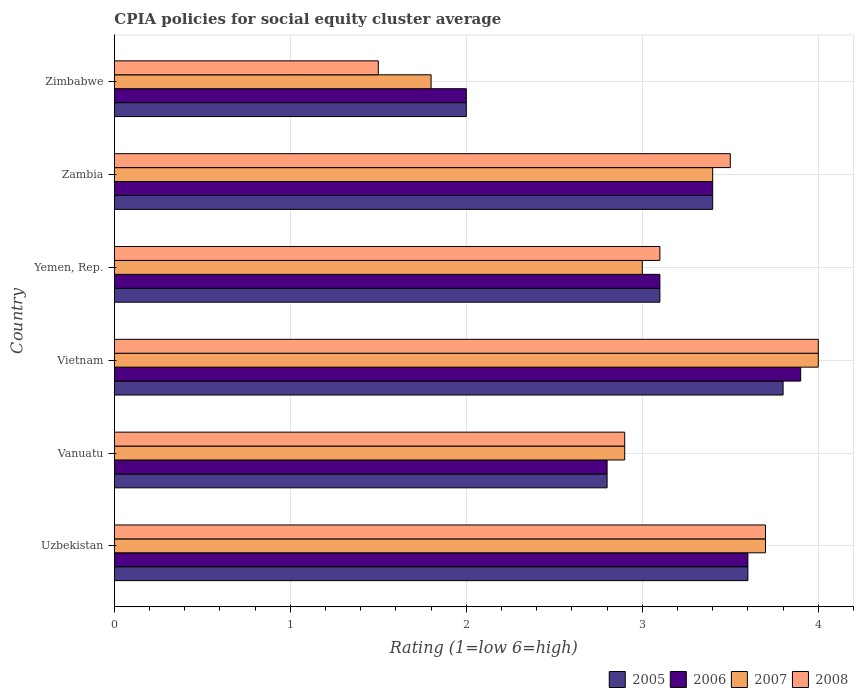Are the number of bars per tick equal to the number of legend labels?
Provide a succinct answer. Yes. How many bars are there on the 4th tick from the bottom?
Make the answer very short. 4. What is the label of the 3rd group of bars from the top?
Your response must be concise. Yemen, Rep. In how many cases, is the number of bars for a given country not equal to the number of legend labels?
Offer a terse response. 0. What is the CPIA rating in 2008 in Yemen, Rep.?
Your answer should be compact. 3.1. Across all countries, what is the maximum CPIA rating in 2006?
Offer a very short reply. 3.9. Across all countries, what is the minimum CPIA rating in 2005?
Offer a terse response. 2. In which country was the CPIA rating in 2006 maximum?
Provide a succinct answer. Vietnam. In which country was the CPIA rating in 2008 minimum?
Keep it short and to the point. Zimbabwe. What is the difference between the CPIA rating in 2006 in Yemen, Rep. and that in Zimbabwe?
Ensure brevity in your answer.  1.1. What is the difference between the CPIA rating in 2008 in Vietnam and the CPIA rating in 2005 in Vanuatu?
Offer a very short reply. 1.2. What is the average CPIA rating in 2007 per country?
Provide a short and direct response. 3.13. What is the difference between the CPIA rating in 2006 and CPIA rating in 2007 in Zimbabwe?
Your answer should be compact. 0.2. What is the ratio of the CPIA rating in 2005 in Uzbekistan to that in Vanuatu?
Offer a terse response. 1.29. Is the difference between the CPIA rating in 2006 in Vietnam and Zimbabwe greater than the difference between the CPIA rating in 2007 in Vietnam and Zimbabwe?
Offer a very short reply. No. What is the difference between the highest and the second highest CPIA rating in 2008?
Your response must be concise. 0.3. What is the difference between the highest and the lowest CPIA rating in 2005?
Keep it short and to the point. 1.8. In how many countries, is the CPIA rating in 2007 greater than the average CPIA rating in 2007 taken over all countries?
Offer a very short reply. 3. Is it the case that in every country, the sum of the CPIA rating in 2007 and CPIA rating in 2008 is greater than the sum of CPIA rating in 2006 and CPIA rating in 2005?
Your response must be concise. No. How many bars are there?
Ensure brevity in your answer.  24. Are all the bars in the graph horizontal?
Your answer should be very brief. Yes. What is the difference between two consecutive major ticks on the X-axis?
Offer a very short reply. 1. Are the values on the major ticks of X-axis written in scientific E-notation?
Ensure brevity in your answer.  No. Does the graph contain grids?
Provide a short and direct response. Yes. Where does the legend appear in the graph?
Provide a short and direct response. Bottom right. How many legend labels are there?
Your response must be concise. 4. What is the title of the graph?
Provide a succinct answer. CPIA policies for social equity cluster average. Does "1988" appear as one of the legend labels in the graph?
Provide a short and direct response. No. What is the label or title of the X-axis?
Your answer should be compact. Rating (1=low 6=high). What is the label or title of the Y-axis?
Offer a very short reply. Country. What is the Rating (1=low 6=high) in 2005 in Uzbekistan?
Your answer should be compact. 3.6. What is the Rating (1=low 6=high) in 2006 in Uzbekistan?
Provide a succinct answer. 3.6. What is the Rating (1=low 6=high) in 2007 in Uzbekistan?
Provide a succinct answer. 3.7. What is the Rating (1=low 6=high) in 2008 in Uzbekistan?
Your response must be concise. 3.7. What is the Rating (1=low 6=high) in 2007 in Vanuatu?
Give a very brief answer. 2.9. What is the Rating (1=low 6=high) in 2005 in Vietnam?
Offer a terse response. 3.8. What is the Rating (1=low 6=high) of 2006 in Yemen, Rep.?
Provide a succinct answer. 3.1. What is the Rating (1=low 6=high) in 2007 in Yemen, Rep.?
Offer a terse response. 3. What is the Rating (1=low 6=high) in 2008 in Yemen, Rep.?
Offer a very short reply. 3.1. What is the Rating (1=low 6=high) of 2006 in Zambia?
Provide a succinct answer. 3.4. What is the Rating (1=low 6=high) of 2007 in Zambia?
Keep it short and to the point. 3.4. What is the Rating (1=low 6=high) of 2008 in Zambia?
Your response must be concise. 3.5. What is the Rating (1=low 6=high) in 2006 in Zimbabwe?
Offer a very short reply. 2. What is the Rating (1=low 6=high) in 2008 in Zimbabwe?
Offer a terse response. 1.5. Across all countries, what is the maximum Rating (1=low 6=high) of 2006?
Your answer should be compact. 3.9. Across all countries, what is the maximum Rating (1=low 6=high) of 2007?
Keep it short and to the point. 4. Across all countries, what is the minimum Rating (1=low 6=high) of 2007?
Provide a short and direct response. 1.8. Across all countries, what is the minimum Rating (1=low 6=high) in 2008?
Your response must be concise. 1.5. What is the total Rating (1=low 6=high) in 2008 in the graph?
Your answer should be very brief. 18.7. What is the difference between the Rating (1=low 6=high) in 2007 in Uzbekistan and that in Vanuatu?
Your response must be concise. 0.8. What is the difference between the Rating (1=low 6=high) of 2005 in Uzbekistan and that in Vietnam?
Provide a succinct answer. -0.2. What is the difference between the Rating (1=low 6=high) in 2006 in Uzbekistan and that in Yemen, Rep.?
Your response must be concise. 0.5. What is the difference between the Rating (1=low 6=high) of 2006 in Uzbekistan and that in Zambia?
Make the answer very short. 0.2. What is the difference between the Rating (1=low 6=high) in 2008 in Uzbekistan and that in Zambia?
Offer a terse response. 0.2. What is the difference between the Rating (1=low 6=high) in 2006 in Uzbekistan and that in Zimbabwe?
Keep it short and to the point. 1.6. What is the difference between the Rating (1=low 6=high) in 2005 in Vanuatu and that in Vietnam?
Provide a succinct answer. -1. What is the difference between the Rating (1=low 6=high) in 2005 in Vanuatu and that in Yemen, Rep.?
Keep it short and to the point. -0.3. What is the difference between the Rating (1=low 6=high) in 2007 in Vanuatu and that in Yemen, Rep.?
Give a very brief answer. -0.1. What is the difference between the Rating (1=low 6=high) of 2006 in Vanuatu and that in Zambia?
Your answer should be very brief. -0.6. What is the difference between the Rating (1=low 6=high) in 2007 in Vanuatu and that in Zambia?
Your answer should be very brief. -0.5. What is the difference between the Rating (1=low 6=high) of 2007 in Vanuatu and that in Zimbabwe?
Give a very brief answer. 1.1. What is the difference between the Rating (1=low 6=high) in 2008 in Vanuatu and that in Zimbabwe?
Provide a succinct answer. 1.4. What is the difference between the Rating (1=low 6=high) in 2007 in Vietnam and that in Yemen, Rep.?
Provide a short and direct response. 1. What is the difference between the Rating (1=low 6=high) of 2008 in Vietnam and that in Yemen, Rep.?
Ensure brevity in your answer.  0.9. What is the difference between the Rating (1=low 6=high) in 2006 in Vietnam and that in Zambia?
Ensure brevity in your answer.  0.5. What is the difference between the Rating (1=low 6=high) of 2008 in Vietnam and that in Zambia?
Your answer should be compact. 0.5. What is the difference between the Rating (1=low 6=high) of 2008 in Vietnam and that in Zimbabwe?
Your response must be concise. 2.5. What is the difference between the Rating (1=low 6=high) in 2005 in Yemen, Rep. and that in Zambia?
Make the answer very short. -0.3. What is the difference between the Rating (1=low 6=high) of 2007 in Yemen, Rep. and that in Zambia?
Your answer should be very brief. -0.4. What is the difference between the Rating (1=low 6=high) in 2006 in Yemen, Rep. and that in Zimbabwe?
Offer a very short reply. 1.1. What is the difference between the Rating (1=low 6=high) in 2008 in Yemen, Rep. and that in Zimbabwe?
Make the answer very short. 1.6. What is the difference between the Rating (1=low 6=high) of 2005 in Zambia and that in Zimbabwe?
Your answer should be very brief. 1.4. What is the difference between the Rating (1=low 6=high) of 2007 in Uzbekistan and the Rating (1=low 6=high) of 2008 in Vanuatu?
Your answer should be compact. 0.8. What is the difference between the Rating (1=low 6=high) in 2005 in Uzbekistan and the Rating (1=low 6=high) in 2007 in Vietnam?
Your answer should be very brief. -0.4. What is the difference between the Rating (1=low 6=high) in 2005 in Uzbekistan and the Rating (1=low 6=high) in 2008 in Vietnam?
Your answer should be compact. -0.4. What is the difference between the Rating (1=low 6=high) of 2006 in Uzbekistan and the Rating (1=low 6=high) of 2007 in Vietnam?
Offer a terse response. -0.4. What is the difference between the Rating (1=low 6=high) in 2006 in Uzbekistan and the Rating (1=low 6=high) in 2008 in Vietnam?
Provide a succinct answer. -0.4. What is the difference between the Rating (1=low 6=high) in 2005 in Uzbekistan and the Rating (1=low 6=high) in 2007 in Yemen, Rep.?
Ensure brevity in your answer.  0.6. What is the difference between the Rating (1=low 6=high) of 2005 in Uzbekistan and the Rating (1=low 6=high) of 2008 in Yemen, Rep.?
Offer a very short reply. 0.5. What is the difference between the Rating (1=low 6=high) in 2006 in Uzbekistan and the Rating (1=low 6=high) in 2007 in Yemen, Rep.?
Make the answer very short. 0.6. What is the difference between the Rating (1=low 6=high) of 2005 in Uzbekistan and the Rating (1=low 6=high) of 2008 in Zambia?
Keep it short and to the point. 0.1. What is the difference between the Rating (1=low 6=high) in 2006 in Uzbekistan and the Rating (1=low 6=high) in 2008 in Zambia?
Your answer should be compact. 0.1. What is the difference between the Rating (1=low 6=high) of 2007 in Uzbekistan and the Rating (1=low 6=high) of 2008 in Zambia?
Offer a terse response. 0.2. What is the difference between the Rating (1=low 6=high) in 2005 in Uzbekistan and the Rating (1=low 6=high) in 2006 in Zimbabwe?
Ensure brevity in your answer.  1.6. What is the difference between the Rating (1=low 6=high) of 2005 in Uzbekistan and the Rating (1=low 6=high) of 2007 in Zimbabwe?
Offer a terse response. 1.8. What is the difference between the Rating (1=low 6=high) of 2007 in Uzbekistan and the Rating (1=low 6=high) of 2008 in Zimbabwe?
Make the answer very short. 2.2. What is the difference between the Rating (1=low 6=high) in 2005 in Vanuatu and the Rating (1=low 6=high) in 2008 in Vietnam?
Keep it short and to the point. -1.2. What is the difference between the Rating (1=low 6=high) in 2006 in Vanuatu and the Rating (1=low 6=high) in 2008 in Vietnam?
Provide a succinct answer. -1.2. What is the difference between the Rating (1=low 6=high) in 2005 in Vanuatu and the Rating (1=low 6=high) in 2006 in Yemen, Rep.?
Your response must be concise. -0.3. What is the difference between the Rating (1=low 6=high) of 2006 in Vanuatu and the Rating (1=low 6=high) of 2007 in Yemen, Rep.?
Provide a short and direct response. -0.2. What is the difference between the Rating (1=low 6=high) in 2005 in Vanuatu and the Rating (1=low 6=high) in 2008 in Zambia?
Provide a succinct answer. -0.7. What is the difference between the Rating (1=low 6=high) in 2006 in Vanuatu and the Rating (1=low 6=high) in 2007 in Zambia?
Make the answer very short. -0.6. What is the difference between the Rating (1=low 6=high) in 2005 in Vanuatu and the Rating (1=low 6=high) in 2006 in Zimbabwe?
Offer a very short reply. 0.8. What is the difference between the Rating (1=low 6=high) of 2005 in Vanuatu and the Rating (1=low 6=high) of 2007 in Zimbabwe?
Offer a terse response. 1. What is the difference between the Rating (1=low 6=high) of 2005 in Vanuatu and the Rating (1=low 6=high) of 2008 in Zimbabwe?
Offer a terse response. 1.3. What is the difference between the Rating (1=low 6=high) of 2006 in Vanuatu and the Rating (1=low 6=high) of 2007 in Zimbabwe?
Your answer should be compact. 1. What is the difference between the Rating (1=low 6=high) of 2006 in Vanuatu and the Rating (1=low 6=high) of 2008 in Zimbabwe?
Offer a terse response. 1.3. What is the difference between the Rating (1=low 6=high) in 2007 in Vanuatu and the Rating (1=low 6=high) in 2008 in Zimbabwe?
Make the answer very short. 1.4. What is the difference between the Rating (1=low 6=high) of 2005 in Vietnam and the Rating (1=low 6=high) of 2006 in Yemen, Rep.?
Keep it short and to the point. 0.7. What is the difference between the Rating (1=low 6=high) in 2005 in Vietnam and the Rating (1=low 6=high) in 2007 in Yemen, Rep.?
Provide a short and direct response. 0.8. What is the difference between the Rating (1=low 6=high) in 2005 in Vietnam and the Rating (1=low 6=high) in 2008 in Yemen, Rep.?
Your response must be concise. 0.7. What is the difference between the Rating (1=low 6=high) of 2006 in Vietnam and the Rating (1=low 6=high) of 2007 in Yemen, Rep.?
Provide a short and direct response. 0.9. What is the difference between the Rating (1=low 6=high) of 2006 in Vietnam and the Rating (1=low 6=high) of 2007 in Zambia?
Your answer should be compact. 0.5. What is the difference between the Rating (1=low 6=high) in 2007 in Vietnam and the Rating (1=low 6=high) in 2008 in Zambia?
Make the answer very short. 0.5. What is the difference between the Rating (1=low 6=high) in 2005 in Yemen, Rep. and the Rating (1=low 6=high) in 2006 in Zambia?
Offer a terse response. -0.3. What is the difference between the Rating (1=low 6=high) of 2005 in Yemen, Rep. and the Rating (1=low 6=high) of 2008 in Zambia?
Offer a terse response. -0.4. What is the difference between the Rating (1=low 6=high) in 2006 in Yemen, Rep. and the Rating (1=low 6=high) in 2007 in Zambia?
Keep it short and to the point. -0.3. What is the difference between the Rating (1=low 6=high) of 2007 in Yemen, Rep. and the Rating (1=low 6=high) of 2008 in Zambia?
Your answer should be very brief. -0.5. What is the difference between the Rating (1=low 6=high) of 2005 in Yemen, Rep. and the Rating (1=low 6=high) of 2006 in Zimbabwe?
Keep it short and to the point. 1.1. What is the difference between the Rating (1=low 6=high) of 2005 in Yemen, Rep. and the Rating (1=low 6=high) of 2008 in Zimbabwe?
Ensure brevity in your answer.  1.6. What is the difference between the Rating (1=low 6=high) of 2006 in Yemen, Rep. and the Rating (1=low 6=high) of 2007 in Zimbabwe?
Keep it short and to the point. 1.3. What is the difference between the Rating (1=low 6=high) in 2006 in Yemen, Rep. and the Rating (1=low 6=high) in 2008 in Zimbabwe?
Offer a very short reply. 1.6. What is the difference between the Rating (1=low 6=high) in 2007 in Yemen, Rep. and the Rating (1=low 6=high) in 2008 in Zimbabwe?
Your response must be concise. 1.5. What is the difference between the Rating (1=low 6=high) of 2005 in Zambia and the Rating (1=low 6=high) of 2006 in Zimbabwe?
Give a very brief answer. 1.4. What is the difference between the Rating (1=low 6=high) of 2007 in Zambia and the Rating (1=low 6=high) of 2008 in Zimbabwe?
Offer a very short reply. 1.9. What is the average Rating (1=low 6=high) of 2005 per country?
Make the answer very short. 3.12. What is the average Rating (1=low 6=high) of 2006 per country?
Ensure brevity in your answer.  3.13. What is the average Rating (1=low 6=high) in 2007 per country?
Your response must be concise. 3.13. What is the average Rating (1=low 6=high) in 2008 per country?
Provide a short and direct response. 3.12. What is the difference between the Rating (1=low 6=high) in 2005 and Rating (1=low 6=high) in 2006 in Uzbekistan?
Your answer should be very brief. 0. What is the difference between the Rating (1=low 6=high) of 2006 and Rating (1=low 6=high) of 2008 in Uzbekistan?
Provide a short and direct response. -0.1. What is the difference between the Rating (1=low 6=high) of 2005 and Rating (1=low 6=high) of 2008 in Vanuatu?
Provide a short and direct response. -0.1. What is the difference between the Rating (1=low 6=high) in 2007 and Rating (1=low 6=high) in 2008 in Vanuatu?
Offer a terse response. 0. What is the difference between the Rating (1=low 6=high) in 2005 and Rating (1=low 6=high) in 2007 in Vietnam?
Give a very brief answer. -0.2. What is the difference between the Rating (1=low 6=high) of 2005 and Rating (1=low 6=high) of 2007 in Yemen, Rep.?
Make the answer very short. 0.1. What is the difference between the Rating (1=low 6=high) in 2006 and Rating (1=low 6=high) in 2008 in Yemen, Rep.?
Keep it short and to the point. 0. What is the difference between the Rating (1=low 6=high) in 2007 and Rating (1=low 6=high) in 2008 in Yemen, Rep.?
Your answer should be very brief. -0.1. What is the difference between the Rating (1=low 6=high) in 2005 and Rating (1=low 6=high) in 2008 in Zambia?
Your answer should be very brief. -0.1. What is the difference between the Rating (1=low 6=high) of 2006 and Rating (1=low 6=high) of 2008 in Zambia?
Your answer should be very brief. -0.1. What is the difference between the Rating (1=low 6=high) of 2007 and Rating (1=low 6=high) of 2008 in Zambia?
Your answer should be very brief. -0.1. What is the difference between the Rating (1=low 6=high) of 2005 and Rating (1=low 6=high) of 2006 in Zimbabwe?
Provide a succinct answer. 0. What is the difference between the Rating (1=low 6=high) in 2006 and Rating (1=low 6=high) in 2008 in Zimbabwe?
Provide a short and direct response. 0.5. What is the ratio of the Rating (1=low 6=high) of 2006 in Uzbekistan to that in Vanuatu?
Provide a short and direct response. 1.29. What is the ratio of the Rating (1=low 6=high) of 2007 in Uzbekistan to that in Vanuatu?
Offer a terse response. 1.28. What is the ratio of the Rating (1=low 6=high) in 2008 in Uzbekistan to that in Vanuatu?
Offer a terse response. 1.28. What is the ratio of the Rating (1=low 6=high) of 2005 in Uzbekistan to that in Vietnam?
Provide a short and direct response. 0.95. What is the ratio of the Rating (1=low 6=high) of 2006 in Uzbekistan to that in Vietnam?
Offer a terse response. 0.92. What is the ratio of the Rating (1=low 6=high) in 2007 in Uzbekistan to that in Vietnam?
Your answer should be compact. 0.93. What is the ratio of the Rating (1=low 6=high) in 2008 in Uzbekistan to that in Vietnam?
Make the answer very short. 0.93. What is the ratio of the Rating (1=low 6=high) in 2005 in Uzbekistan to that in Yemen, Rep.?
Ensure brevity in your answer.  1.16. What is the ratio of the Rating (1=low 6=high) of 2006 in Uzbekistan to that in Yemen, Rep.?
Your response must be concise. 1.16. What is the ratio of the Rating (1=low 6=high) of 2007 in Uzbekistan to that in Yemen, Rep.?
Provide a short and direct response. 1.23. What is the ratio of the Rating (1=low 6=high) in 2008 in Uzbekistan to that in Yemen, Rep.?
Your response must be concise. 1.19. What is the ratio of the Rating (1=low 6=high) of 2005 in Uzbekistan to that in Zambia?
Make the answer very short. 1.06. What is the ratio of the Rating (1=low 6=high) of 2006 in Uzbekistan to that in Zambia?
Provide a short and direct response. 1.06. What is the ratio of the Rating (1=low 6=high) in 2007 in Uzbekistan to that in Zambia?
Keep it short and to the point. 1.09. What is the ratio of the Rating (1=low 6=high) of 2008 in Uzbekistan to that in Zambia?
Offer a very short reply. 1.06. What is the ratio of the Rating (1=low 6=high) in 2005 in Uzbekistan to that in Zimbabwe?
Your answer should be very brief. 1.8. What is the ratio of the Rating (1=low 6=high) in 2007 in Uzbekistan to that in Zimbabwe?
Your answer should be compact. 2.06. What is the ratio of the Rating (1=low 6=high) of 2008 in Uzbekistan to that in Zimbabwe?
Offer a terse response. 2.47. What is the ratio of the Rating (1=low 6=high) of 2005 in Vanuatu to that in Vietnam?
Provide a short and direct response. 0.74. What is the ratio of the Rating (1=low 6=high) of 2006 in Vanuatu to that in Vietnam?
Offer a terse response. 0.72. What is the ratio of the Rating (1=low 6=high) in 2007 in Vanuatu to that in Vietnam?
Provide a short and direct response. 0.72. What is the ratio of the Rating (1=low 6=high) in 2008 in Vanuatu to that in Vietnam?
Give a very brief answer. 0.72. What is the ratio of the Rating (1=low 6=high) of 2005 in Vanuatu to that in Yemen, Rep.?
Provide a succinct answer. 0.9. What is the ratio of the Rating (1=low 6=high) in 2006 in Vanuatu to that in Yemen, Rep.?
Give a very brief answer. 0.9. What is the ratio of the Rating (1=low 6=high) of 2007 in Vanuatu to that in Yemen, Rep.?
Provide a succinct answer. 0.97. What is the ratio of the Rating (1=low 6=high) in 2008 in Vanuatu to that in Yemen, Rep.?
Provide a succinct answer. 0.94. What is the ratio of the Rating (1=low 6=high) in 2005 in Vanuatu to that in Zambia?
Your response must be concise. 0.82. What is the ratio of the Rating (1=low 6=high) in 2006 in Vanuatu to that in Zambia?
Provide a succinct answer. 0.82. What is the ratio of the Rating (1=low 6=high) of 2007 in Vanuatu to that in Zambia?
Offer a terse response. 0.85. What is the ratio of the Rating (1=low 6=high) of 2008 in Vanuatu to that in Zambia?
Offer a very short reply. 0.83. What is the ratio of the Rating (1=low 6=high) of 2006 in Vanuatu to that in Zimbabwe?
Provide a short and direct response. 1.4. What is the ratio of the Rating (1=low 6=high) in 2007 in Vanuatu to that in Zimbabwe?
Keep it short and to the point. 1.61. What is the ratio of the Rating (1=low 6=high) of 2008 in Vanuatu to that in Zimbabwe?
Keep it short and to the point. 1.93. What is the ratio of the Rating (1=low 6=high) in 2005 in Vietnam to that in Yemen, Rep.?
Provide a succinct answer. 1.23. What is the ratio of the Rating (1=low 6=high) in 2006 in Vietnam to that in Yemen, Rep.?
Your response must be concise. 1.26. What is the ratio of the Rating (1=low 6=high) of 2007 in Vietnam to that in Yemen, Rep.?
Your answer should be very brief. 1.33. What is the ratio of the Rating (1=low 6=high) of 2008 in Vietnam to that in Yemen, Rep.?
Ensure brevity in your answer.  1.29. What is the ratio of the Rating (1=low 6=high) of 2005 in Vietnam to that in Zambia?
Your answer should be compact. 1.12. What is the ratio of the Rating (1=low 6=high) in 2006 in Vietnam to that in Zambia?
Your answer should be very brief. 1.15. What is the ratio of the Rating (1=low 6=high) in 2007 in Vietnam to that in Zambia?
Make the answer very short. 1.18. What is the ratio of the Rating (1=low 6=high) of 2008 in Vietnam to that in Zambia?
Your response must be concise. 1.14. What is the ratio of the Rating (1=low 6=high) of 2005 in Vietnam to that in Zimbabwe?
Make the answer very short. 1.9. What is the ratio of the Rating (1=low 6=high) of 2006 in Vietnam to that in Zimbabwe?
Provide a succinct answer. 1.95. What is the ratio of the Rating (1=low 6=high) in 2007 in Vietnam to that in Zimbabwe?
Make the answer very short. 2.22. What is the ratio of the Rating (1=low 6=high) in 2008 in Vietnam to that in Zimbabwe?
Give a very brief answer. 2.67. What is the ratio of the Rating (1=low 6=high) in 2005 in Yemen, Rep. to that in Zambia?
Offer a very short reply. 0.91. What is the ratio of the Rating (1=low 6=high) in 2006 in Yemen, Rep. to that in Zambia?
Offer a terse response. 0.91. What is the ratio of the Rating (1=low 6=high) in 2007 in Yemen, Rep. to that in Zambia?
Your response must be concise. 0.88. What is the ratio of the Rating (1=low 6=high) of 2008 in Yemen, Rep. to that in Zambia?
Keep it short and to the point. 0.89. What is the ratio of the Rating (1=low 6=high) in 2005 in Yemen, Rep. to that in Zimbabwe?
Your response must be concise. 1.55. What is the ratio of the Rating (1=low 6=high) in 2006 in Yemen, Rep. to that in Zimbabwe?
Give a very brief answer. 1.55. What is the ratio of the Rating (1=low 6=high) in 2008 in Yemen, Rep. to that in Zimbabwe?
Provide a succinct answer. 2.07. What is the ratio of the Rating (1=low 6=high) of 2005 in Zambia to that in Zimbabwe?
Your answer should be very brief. 1.7. What is the ratio of the Rating (1=low 6=high) in 2007 in Zambia to that in Zimbabwe?
Provide a short and direct response. 1.89. What is the ratio of the Rating (1=low 6=high) of 2008 in Zambia to that in Zimbabwe?
Your answer should be very brief. 2.33. What is the difference between the highest and the second highest Rating (1=low 6=high) in 2006?
Make the answer very short. 0.3. What is the difference between the highest and the second highest Rating (1=low 6=high) of 2008?
Make the answer very short. 0.3. What is the difference between the highest and the lowest Rating (1=low 6=high) in 2005?
Offer a very short reply. 1.8. What is the difference between the highest and the lowest Rating (1=low 6=high) in 2006?
Offer a terse response. 1.9. What is the difference between the highest and the lowest Rating (1=low 6=high) of 2008?
Provide a succinct answer. 2.5. 